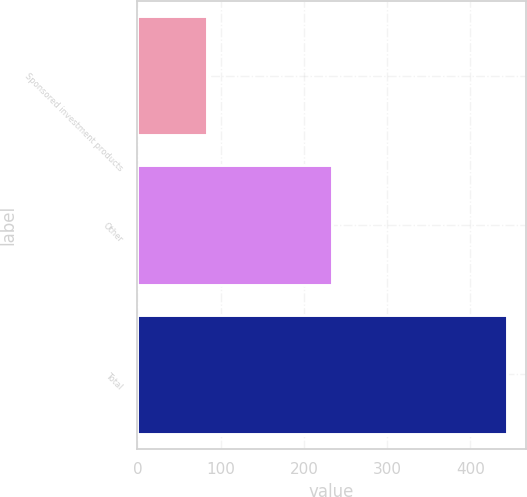Convert chart to OTSL. <chart><loc_0><loc_0><loc_500><loc_500><bar_chart><fcel>Sponsored investment products<fcel>Other<fcel>Total<nl><fcel>84<fcel>234<fcel>444<nl></chart> 